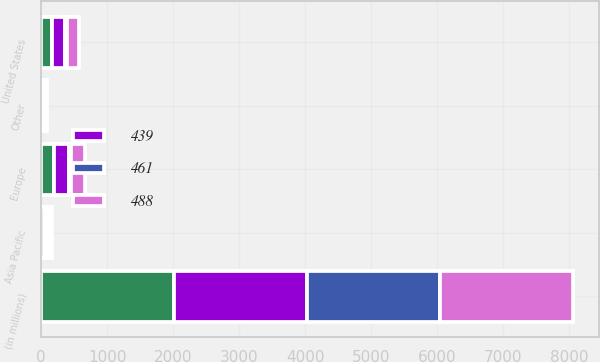Convert chart to OTSL. <chart><loc_0><loc_0><loc_500><loc_500><stacked_bar_chart><ecel><fcel>(in millions)<fcel>United States<fcel>Europe<fcel>Asia Pacific<fcel>Other<nl><fcel>nan<fcel>2015<fcel>168<fcel>189<fcel>56<fcel>26<nl><fcel>461<fcel>2015<fcel>38<fcel>43<fcel>13<fcel>6<nl><fcel>488<fcel>2014<fcel>180<fcel>206<fcel>53<fcel>22<nl><fcel>439<fcel>2013<fcel>186<fcel>225<fcel>45<fcel>32<nl></chart> 